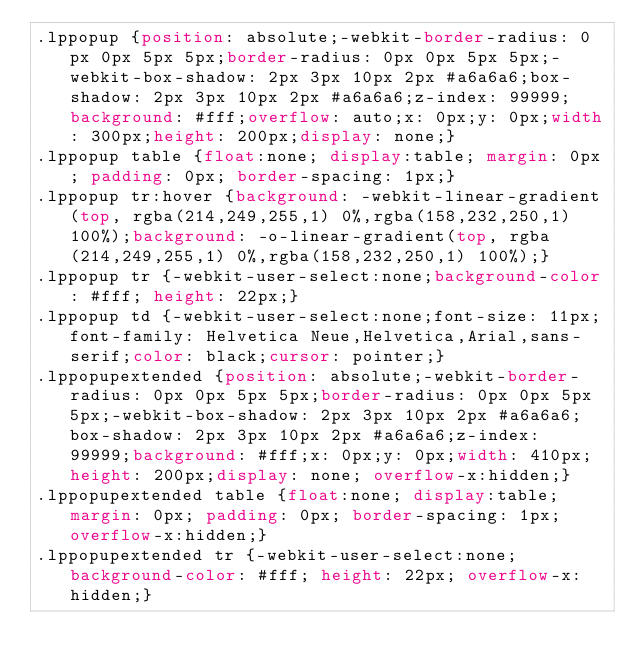<code> <loc_0><loc_0><loc_500><loc_500><_CSS_>.lppopup {position: absolute;-webkit-border-radius: 0px 0px 5px 5px;border-radius: 0px 0px 5px 5px;-webkit-box-shadow: 2px 3px 10px 2px #a6a6a6;box-shadow: 2px 3px 10px 2px #a6a6a6;z-index: 99999;background: #fff;overflow: auto;x: 0px;y: 0px;width: 300px;height: 200px;display: none;}
.lppopup table {float:none; display:table; margin: 0px; padding: 0px; border-spacing: 1px;}
.lppopup tr:hover {background: -webkit-linear-gradient(top, rgba(214,249,255,1) 0%,rgba(158,232,250,1) 100%);background: -o-linear-gradient(top, rgba(214,249,255,1) 0%,rgba(158,232,250,1) 100%);}
.lppopup tr {-webkit-user-select:none;background-color: #fff; height: 22px;}
.lppopup td {-webkit-user-select:none;font-size: 11px;font-family: Helvetica Neue,Helvetica,Arial,sans-serif;color: black;cursor: pointer;}
.lppopupextended {position: absolute;-webkit-border-radius: 0px 0px 5px 5px;border-radius: 0px 0px 5px 5px;-webkit-box-shadow: 2px 3px 10px 2px #a6a6a6;box-shadow: 2px 3px 10px 2px #a6a6a6;z-index: 99999;background: #fff;x: 0px;y: 0px;width: 410px;height: 200px;display: none; overflow-x:hidden;}
.lppopupextended table {float:none; display:table; margin: 0px; padding: 0px; border-spacing: 1px; overflow-x:hidden;}
.lppopupextended tr {-webkit-user-select:none;background-color: #fff; height: 22px; overflow-x:hidden;}</code> 